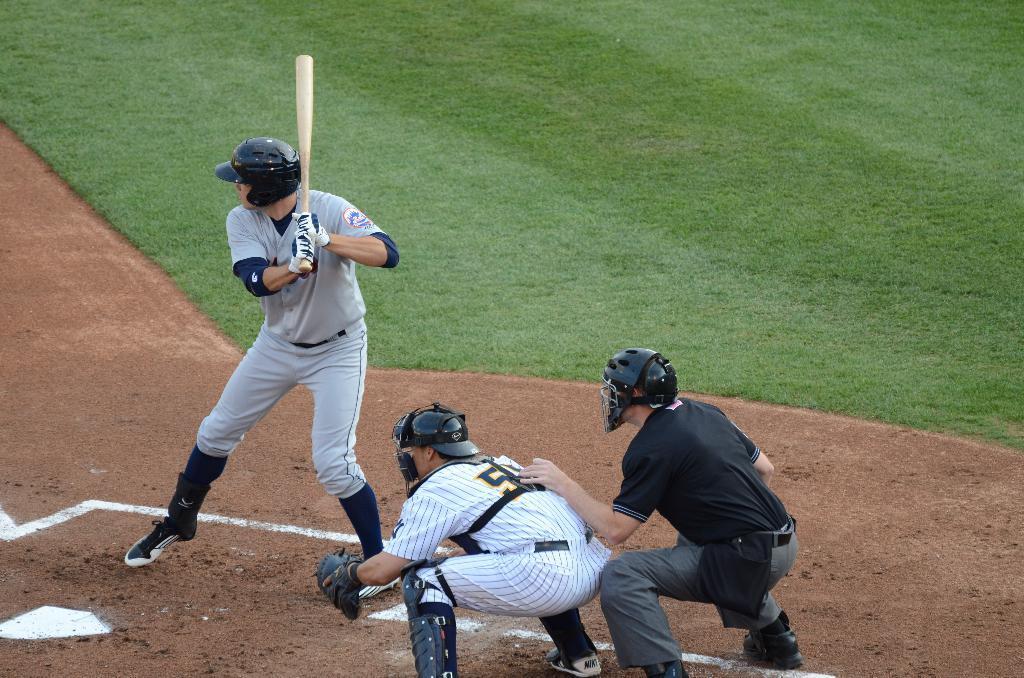How would you summarize this image in a sentence or two? There are two men in squat position on the ground and a man is standing by holding a bat in his hands and all of them have helmets on their heads. In the background we can see grass on the ground. 